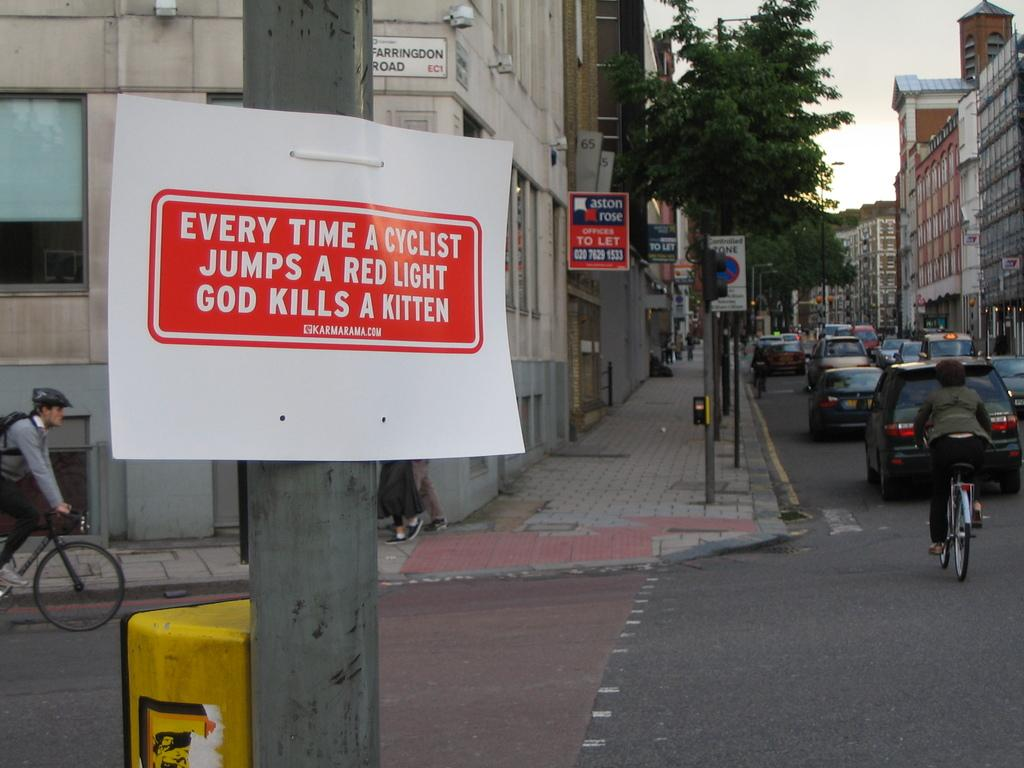What is happening on the road in the image? Vehicles are passing on the road in the image. What activity are people engaged in within the image? People are cycling in the image. What type of structures can be seen in the image? There are poles, boards, trees, and buildings visible in the image. What part of the natural environment is visible in the image? The sky is visible in the image. Can you see a horse riding through the rainstorm in the image? There is no horse or rainstorm present in the image. Is there a throne visible in the image? There is no throne present in the image. 